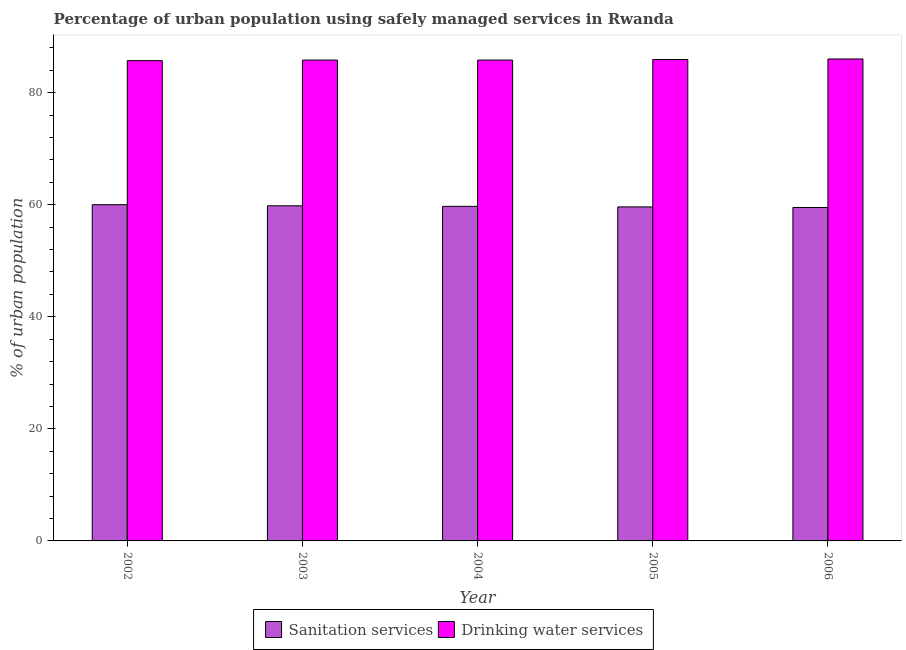What is the label of the 1st group of bars from the left?
Offer a very short reply. 2002. What is the percentage of urban population who used sanitation services in 2005?
Ensure brevity in your answer.  59.6. Across all years, what is the maximum percentage of urban population who used sanitation services?
Provide a short and direct response. 60. Across all years, what is the minimum percentage of urban population who used sanitation services?
Your response must be concise. 59.5. What is the total percentage of urban population who used drinking water services in the graph?
Offer a terse response. 429.2. What is the difference between the percentage of urban population who used sanitation services in 2002 and that in 2005?
Keep it short and to the point. 0.4. What is the difference between the percentage of urban population who used drinking water services in 2006 and the percentage of urban population who used sanitation services in 2002?
Your answer should be compact. 0.3. What is the average percentage of urban population who used drinking water services per year?
Offer a very short reply. 85.84. In the year 2006, what is the difference between the percentage of urban population who used drinking water services and percentage of urban population who used sanitation services?
Provide a short and direct response. 0. In how many years, is the percentage of urban population who used sanitation services greater than 44 %?
Offer a terse response. 5. What is the ratio of the percentage of urban population who used drinking water services in 2002 to that in 2003?
Give a very brief answer. 1. Is the percentage of urban population who used drinking water services in 2005 less than that in 2006?
Provide a succinct answer. Yes. What is the difference between the highest and the second highest percentage of urban population who used sanitation services?
Ensure brevity in your answer.  0.2. What is the difference between the highest and the lowest percentage of urban population who used drinking water services?
Make the answer very short. 0.3. In how many years, is the percentage of urban population who used drinking water services greater than the average percentage of urban population who used drinking water services taken over all years?
Ensure brevity in your answer.  2. What does the 1st bar from the left in 2003 represents?
Provide a short and direct response. Sanitation services. What does the 2nd bar from the right in 2005 represents?
Make the answer very short. Sanitation services. How many bars are there?
Your answer should be compact. 10. What is the difference between two consecutive major ticks on the Y-axis?
Offer a terse response. 20. Where does the legend appear in the graph?
Give a very brief answer. Bottom center. What is the title of the graph?
Give a very brief answer. Percentage of urban population using safely managed services in Rwanda. What is the label or title of the Y-axis?
Offer a very short reply. % of urban population. What is the % of urban population in Sanitation services in 2002?
Provide a succinct answer. 60. What is the % of urban population of Drinking water services in 2002?
Ensure brevity in your answer.  85.7. What is the % of urban population of Sanitation services in 2003?
Your response must be concise. 59.8. What is the % of urban population in Drinking water services in 2003?
Offer a very short reply. 85.8. What is the % of urban population in Sanitation services in 2004?
Provide a short and direct response. 59.7. What is the % of urban population of Drinking water services in 2004?
Make the answer very short. 85.8. What is the % of urban population of Sanitation services in 2005?
Provide a succinct answer. 59.6. What is the % of urban population of Drinking water services in 2005?
Offer a very short reply. 85.9. What is the % of urban population in Sanitation services in 2006?
Provide a short and direct response. 59.5. Across all years, what is the maximum % of urban population of Sanitation services?
Offer a very short reply. 60. Across all years, what is the maximum % of urban population in Drinking water services?
Keep it short and to the point. 86. Across all years, what is the minimum % of urban population in Sanitation services?
Your answer should be compact. 59.5. Across all years, what is the minimum % of urban population in Drinking water services?
Your answer should be compact. 85.7. What is the total % of urban population of Sanitation services in the graph?
Your answer should be compact. 298.6. What is the total % of urban population in Drinking water services in the graph?
Offer a very short reply. 429.2. What is the difference between the % of urban population in Drinking water services in 2002 and that in 2003?
Give a very brief answer. -0.1. What is the difference between the % of urban population in Drinking water services in 2002 and that in 2006?
Keep it short and to the point. -0.3. What is the difference between the % of urban population of Sanitation services in 2003 and that in 2004?
Provide a succinct answer. 0.1. What is the difference between the % of urban population of Drinking water services in 2003 and that in 2006?
Your answer should be very brief. -0.2. What is the difference between the % of urban population in Drinking water services in 2004 and that in 2005?
Ensure brevity in your answer.  -0.1. What is the difference between the % of urban population in Drinking water services in 2004 and that in 2006?
Ensure brevity in your answer.  -0.2. What is the difference between the % of urban population in Drinking water services in 2005 and that in 2006?
Keep it short and to the point. -0.1. What is the difference between the % of urban population of Sanitation services in 2002 and the % of urban population of Drinking water services in 2003?
Offer a terse response. -25.8. What is the difference between the % of urban population in Sanitation services in 2002 and the % of urban population in Drinking water services in 2004?
Your answer should be compact. -25.8. What is the difference between the % of urban population in Sanitation services in 2002 and the % of urban population in Drinking water services in 2005?
Offer a terse response. -25.9. What is the difference between the % of urban population in Sanitation services in 2003 and the % of urban population in Drinking water services in 2004?
Offer a terse response. -26. What is the difference between the % of urban population of Sanitation services in 2003 and the % of urban population of Drinking water services in 2005?
Give a very brief answer. -26.1. What is the difference between the % of urban population of Sanitation services in 2003 and the % of urban population of Drinking water services in 2006?
Offer a very short reply. -26.2. What is the difference between the % of urban population in Sanitation services in 2004 and the % of urban population in Drinking water services in 2005?
Your answer should be compact. -26.2. What is the difference between the % of urban population in Sanitation services in 2004 and the % of urban population in Drinking water services in 2006?
Make the answer very short. -26.3. What is the difference between the % of urban population in Sanitation services in 2005 and the % of urban population in Drinking water services in 2006?
Your answer should be compact. -26.4. What is the average % of urban population of Sanitation services per year?
Give a very brief answer. 59.72. What is the average % of urban population of Drinking water services per year?
Provide a short and direct response. 85.84. In the year 2002, what is the difference between the % of urban population in Sanitation services and % of urban population in Drinking water services?
Offer a very short reply. -25.7. In the year 2003, what is the difference between the % of urban population in Sanitation services and % of urban population in Drinking water services?
Give a very brief answer. -26. In the year 2004, what is the difference between the % of urban population in Sanitation services and % of urban population in Drinking water services?
Offer a terse response. -26.1. In the year 2005, what is the difference between the % of urban population of Sanitation services and % of urban population of Drinking water services?
Ensure brevity in your answer.  -26.3. In the year 2006, what is the difference between the % of urban population of Sanitation services and % of urban population of Drinking water services?
Give a very brief answer. -26.5. What is the ratio of the % of urban population of Sanitation services in 2002 to that in 2003?
Ensure brevity in your answer.  1. What is the ratio of the % of urban population of Drinking water services in 2002 to that in 2003?
Give a very brief answer. 1. What is the ratio of the % of urban population of Sanitation services in 2002 to that in 2004?
Keep it short and to the point. 1. What is the ratio of the % of urban population in Drinking water services in 2002 to that in 2005?
Offer a terse response. 1. What is the ratio of the % of urban population in Sanitation services in 2002 to that in 2006?
Your answer should be compact. 1.01. What is the ratio of the % of urban population in Drinking water services in 2003 to that in 2004?
Your answer should be compact. 1. What is the ratio of the % of urban population of Sanitation services in 2003 to that in 2005?
Your answer should be very brief. 1. What is the ratio of the % of urban population of Sanitation services in 2003 to that in 2006?
Your answer should be very brief. 1. What is the ratio of the % of urban population in Drinking water services in 2003 to that in 2006?
Your answer should be compact. 1. What is the ratio of the % of urban population in Sanitation services in 2004 to that in 2005?
Offer a very short reply. 1. What is the ratio of the % of urban population in Sanitation services in 2004 to that in 2006?
Your answer should be very brief. 1. What is the ratio of the % of urban population of Drinking water services in 2004 to that in 2006?
Provide a short and direct response. 1. What is the ratio of the % of urban population in Sanitation services in 2005 to that in 2006?
Provide a short and direct response. 1. What is the difference between the highest and the second highest % of urban population in Drinking water services?
Ensure brevity in your answer.  0.1. What is the difference between the highest and the lowest % of urban population in Sanitation services?
Provide a succinct answer. 0.5. 